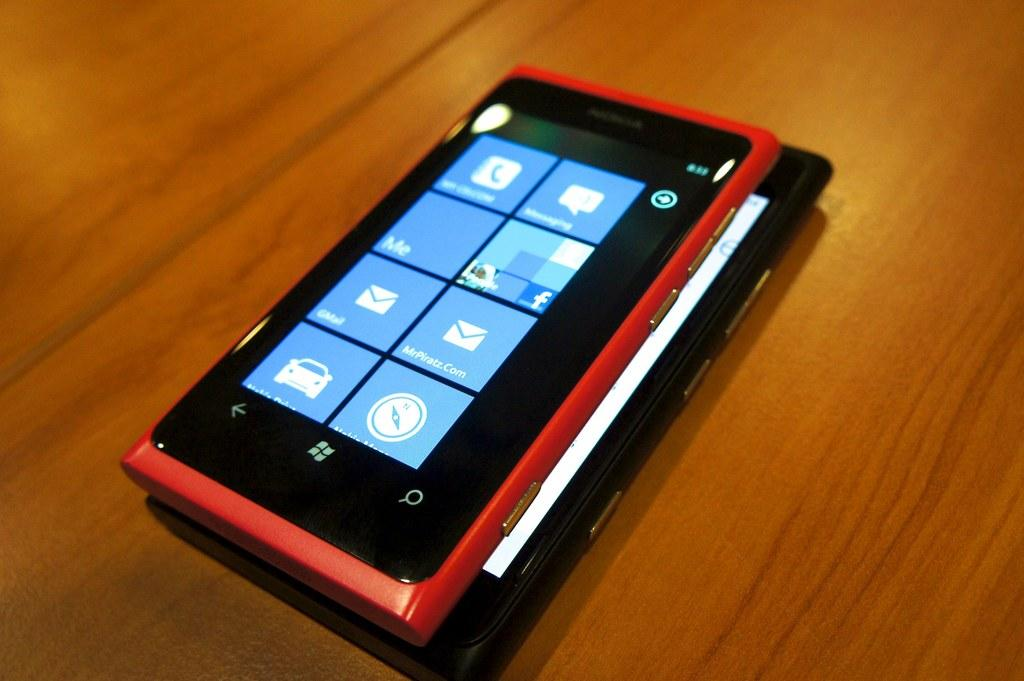<image>
Offer a succinct explanation of the picture presented. A red and black smartphone running a windows operating system. 